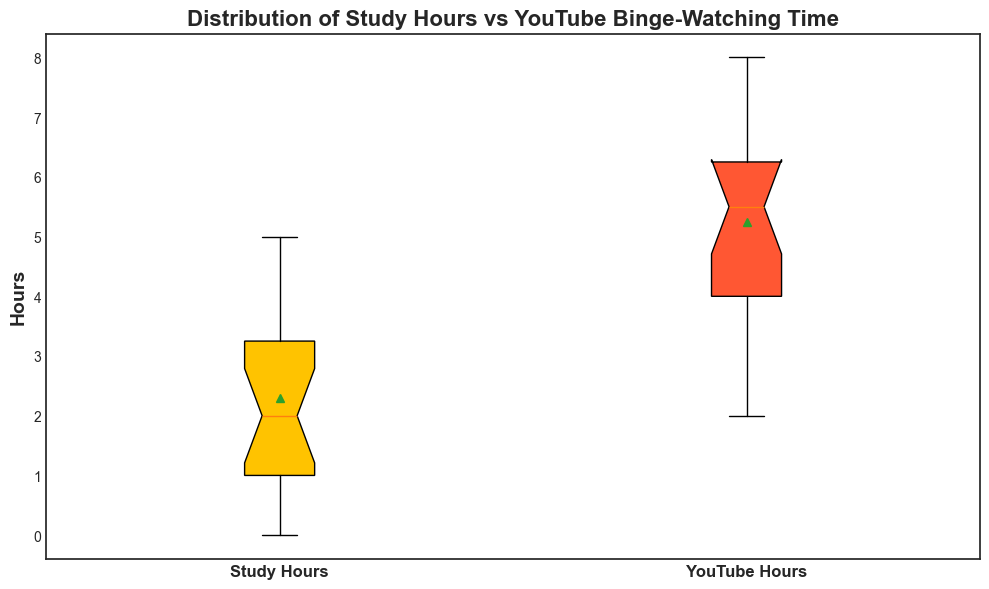What's the median value of study hours? The box plot shows a horizontal line within the box that represents the median value. For study hours, that line is at the middle of the box, which is around 2.
Answer: 2 Which group has a higher median, Study Hours or YouTube Hours? By comparing the horizontal lines within the boxes, the median for YouTube hours is higher than that for study hours.
Answer: YouTube Hours What are the lower and upper whiskers of YouTube hours? The lower whisker represents the minimum value, and the upper whisker represents the maximum value, excluding outliers. For YouTube hours, the lower whisker touches 3, and the upper whisker reaches 8.
Answer: 3, 8 What is the interquartile range (IQR) for study hours? The IQR is the difference between the upper quartile (75th percentile) and the lower quartile (25th percentile). The box plot shows the box range from 1 to 4 for study hours. Therefore, the IQR is 4 - 1 = 3.
Answer: 3 Which group has a larger interquartile range (IQR), Study Hours or YouTube Hours? You can determine the IQR for each group by measuring the box lengths. For study hours, the IQR is 3 (4 - 1). For YouTube hours, the IQR is 3 as well (6 - 3). Therefore, both groups have the same IQR.
Answer: Both are equal Is there an outlier in the study hours group? In box plots, outliers are usually marked by points above or below the whiskers. In the study hours box plot, there are no points outside the whiskers.
Answer: No From the mean values displayed, which activity do students spend more time on? The mean (marked by a small square or a line) for YouTube hours is higher than the mean for study hours, indicating that students spend more time on YouTube.
Answer: YouTube Hours How does the distribution shape of Study Hours differ from YouTube Hours visually? The study hours distribution is right-skewed since the median is closer to the lower quartile. The YouTube hours distribution does not appear skewed as the median is well-centered.
Answer: Study Hours: right-skewed, YouTube Hours: not skewed What can you infer about the range of study hours compared to the range of YouTube hours? The range is the difference between the maximum and minimum values. Study hours range from 0 to 5 while YouTube hours range from 3 to 8. The range for YouTube hours (5) is larger than that of study hours (5 - 0 = 5).
Answer: Equal 